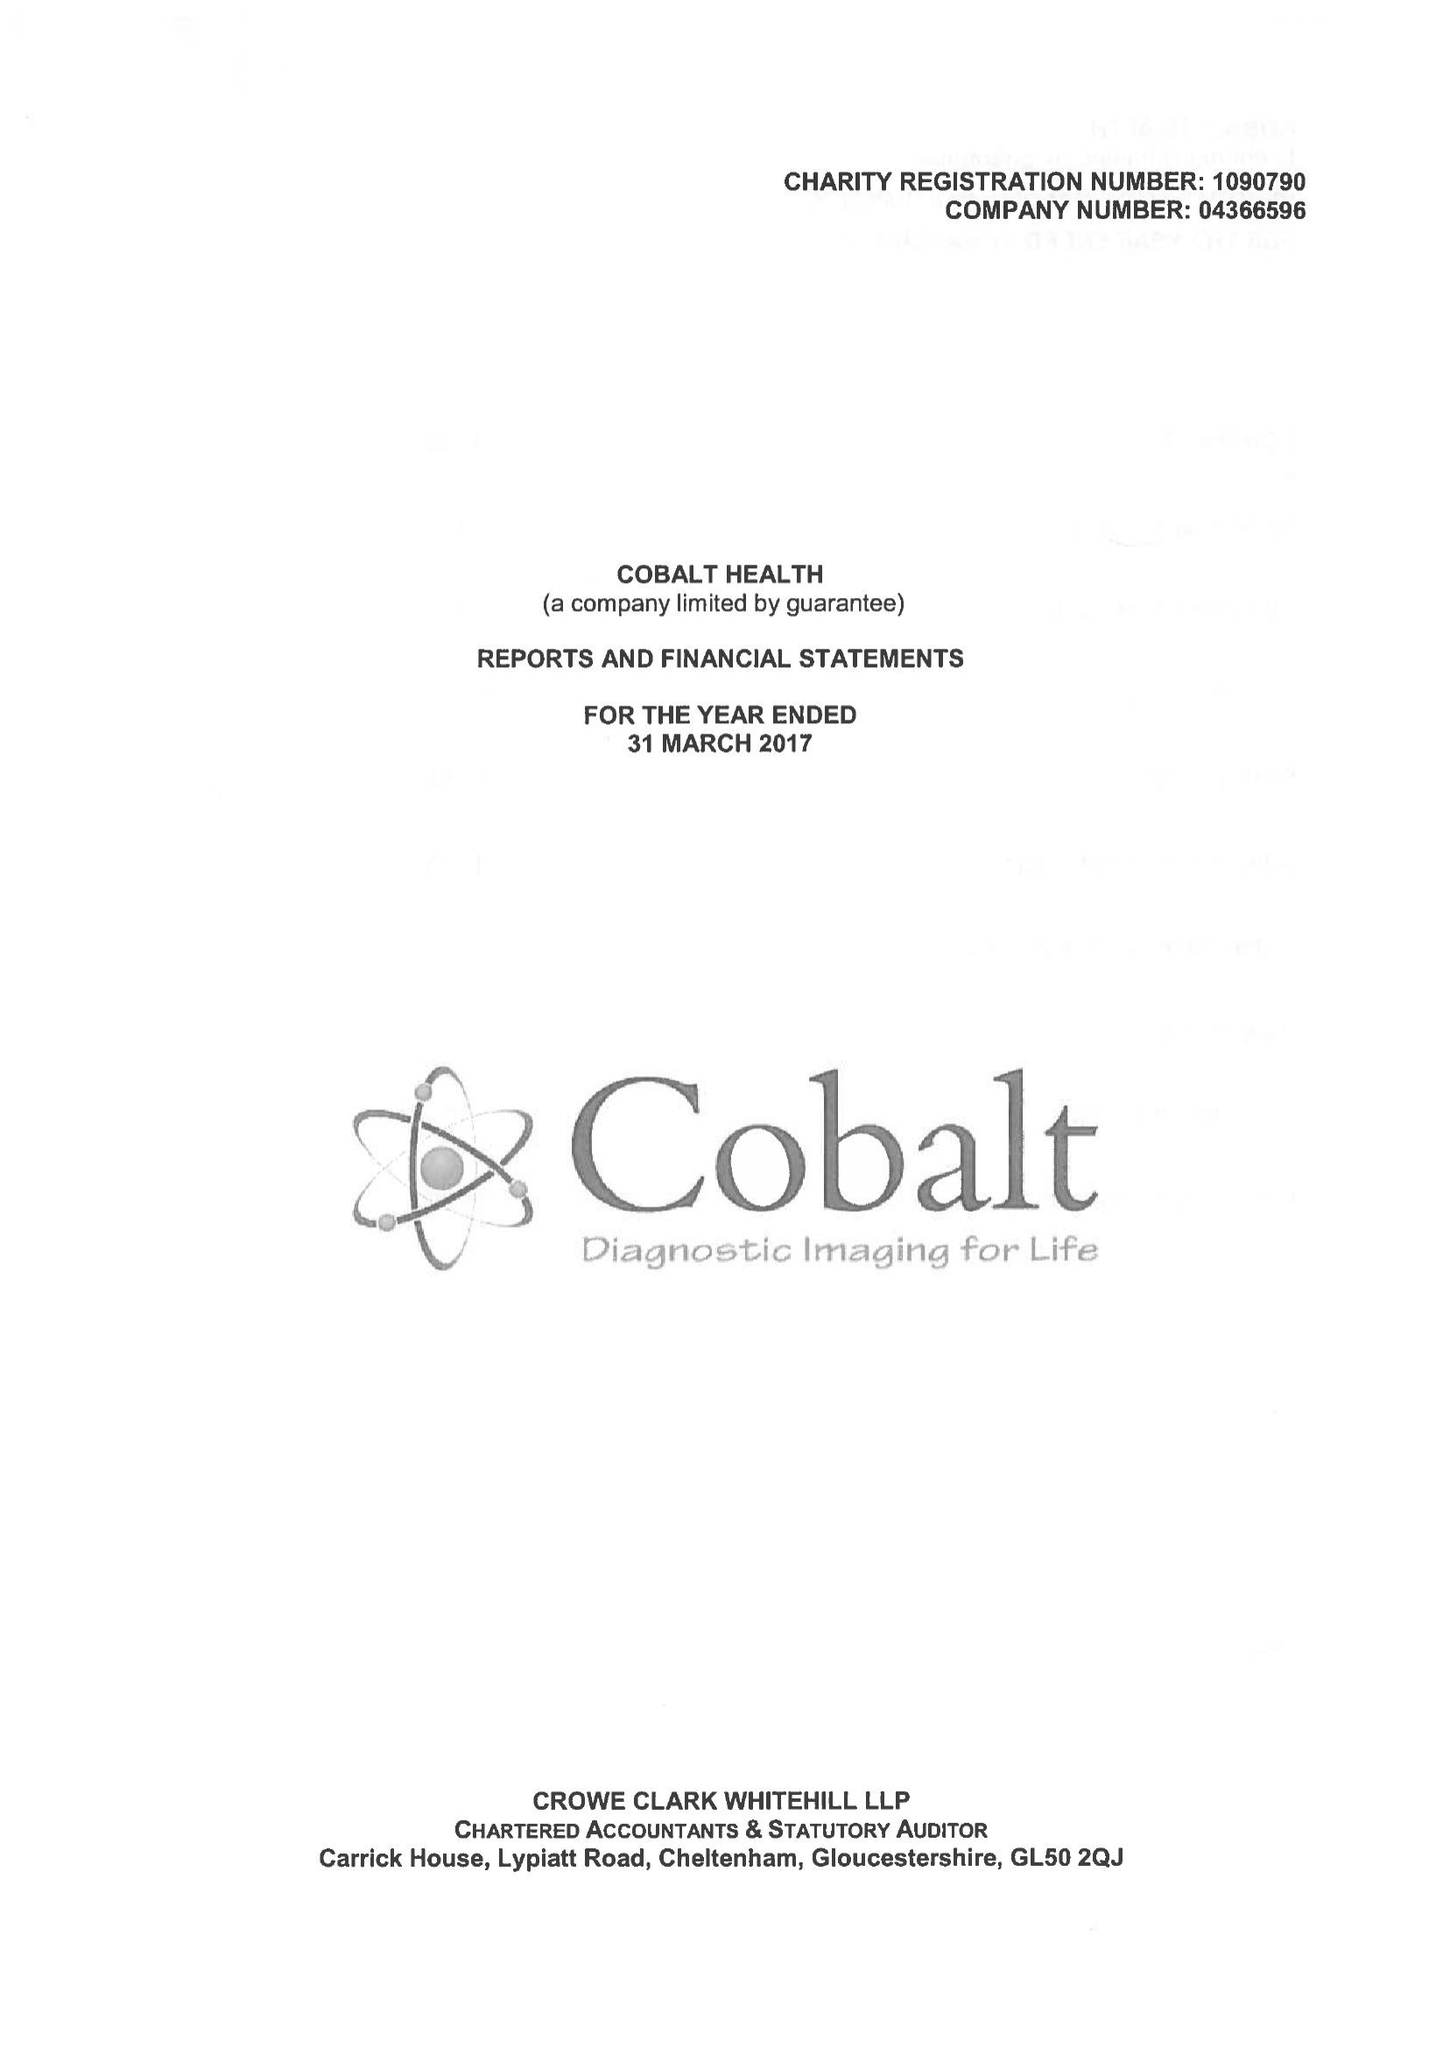What is the value for the charity_name?
Answer the question using a single word or phrase. Cobalt Health 